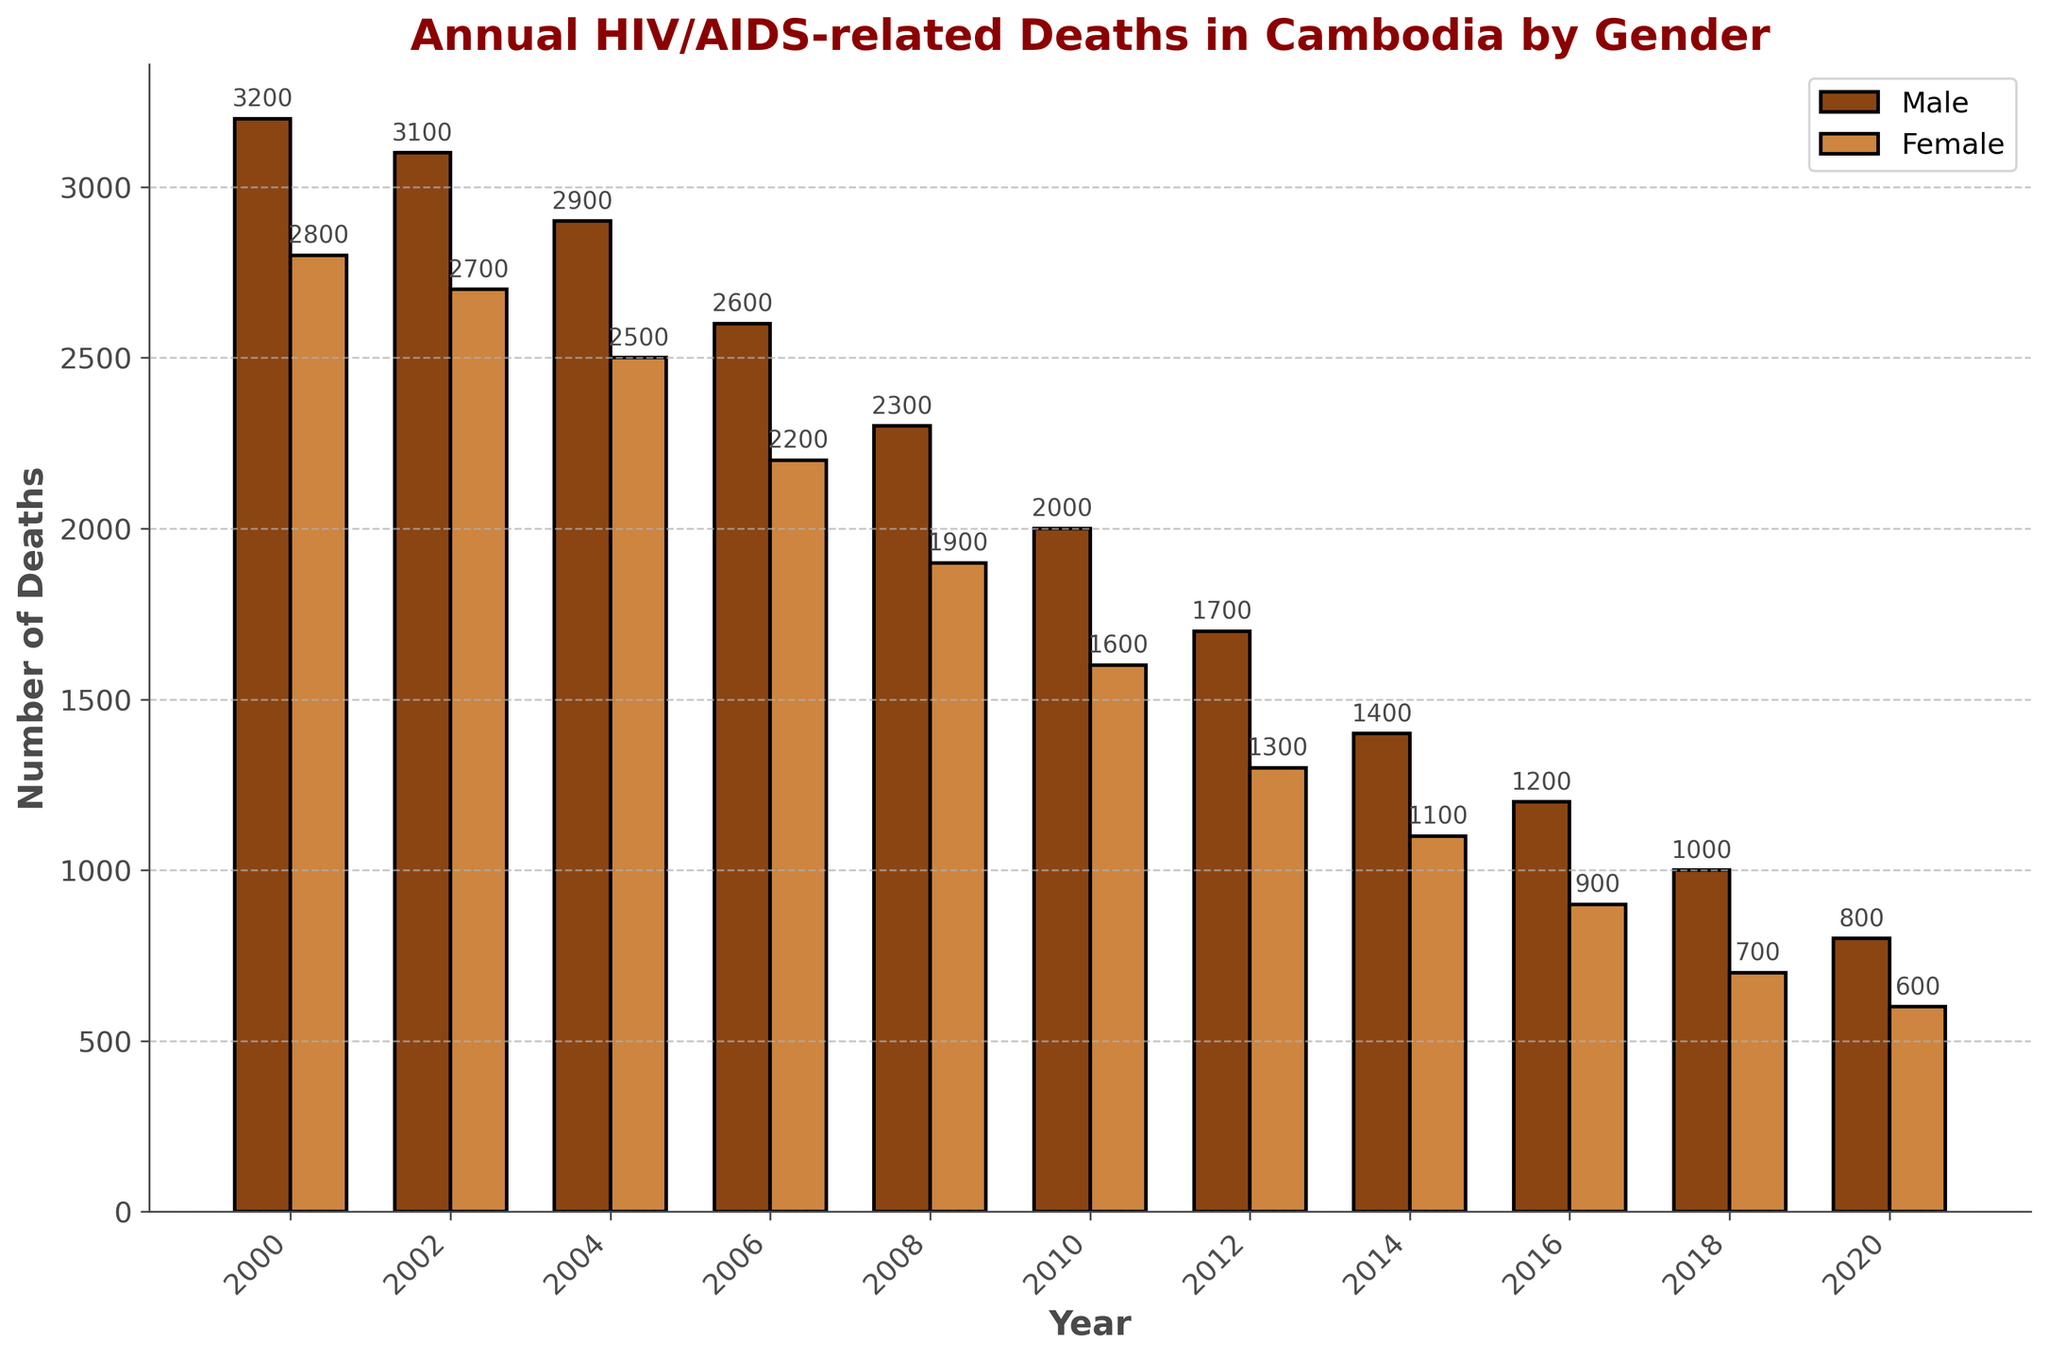Which year had the highest number of male deaths? By looking at the heights of the bars for male deaths, the year 2000 has the tallest bar, indicating the highest number of male deaths.
Answer: 2000 Which gender experienced a greater reduction in deaths from 2000 to 2020? To find the reduction, subtract the number of deaths in 2020 from 2000 for each gender. For males: 3200 - 800 = 2400. For females: 2800 - 600 = 2200. Males had a greater reduction in deaths.
Answer: Male What is the difference in the number of deaths between males and females in 2012? Subtract the number of female deaths from male deaths in the year 2012. Male deaths: 1700, Female deaths: 1300. Difference: 1700 - 1300 = 400.
Answer: 400 In which year did male and female deaths both drop below 2000 for the first time? Observing the bar height for both genders, both male and female deaths drop below 2000 in 2010.
Answer: 2010 What is the sum of male and female deaths in 2004? Add the male and female deaths for the year 2004. Male deaths: 2900, Female deaths: 2500. Sum: 2900 + 2500 = 5400.
Answer: 5400 By how much did female deaths decrease from 2010 to 2016? Subtract the number of female deaths in 2016 from 2010. Female deaths in 2010: 1600, Female deaths in 2016: 900. Decrease: 1600 - 900 = 700.
Answer: 700 Which year shows the highest combined number of deaths for both genders? By summing the male and female deaths for each year and comparing, the year 2000 has the highest combined deaths. Male: 3200, Female: 2800. Combined: 3200 + 2800 = 6000.
Answer: 2000 Is the number of male deaths in 2002 greater than the number of female deaths in 2004? Compare male deaths in 2002, which is 3100, to female deaths in 2004, which is 2500. Since 3100 is greater than 2500, the answer is yes.
Answer: Yes What is the percentage decrease in male deaths from 2008 to 2020? First, find the decrease: Male deaths in 2008: 2300, Male deaths in 2020: 800. Decrease: 2300 - 800 = 1500. Then, calculate the percentage decrease: (1500 / 2300) * 100 ≈ 65.2%.
Answer: 65.2% 